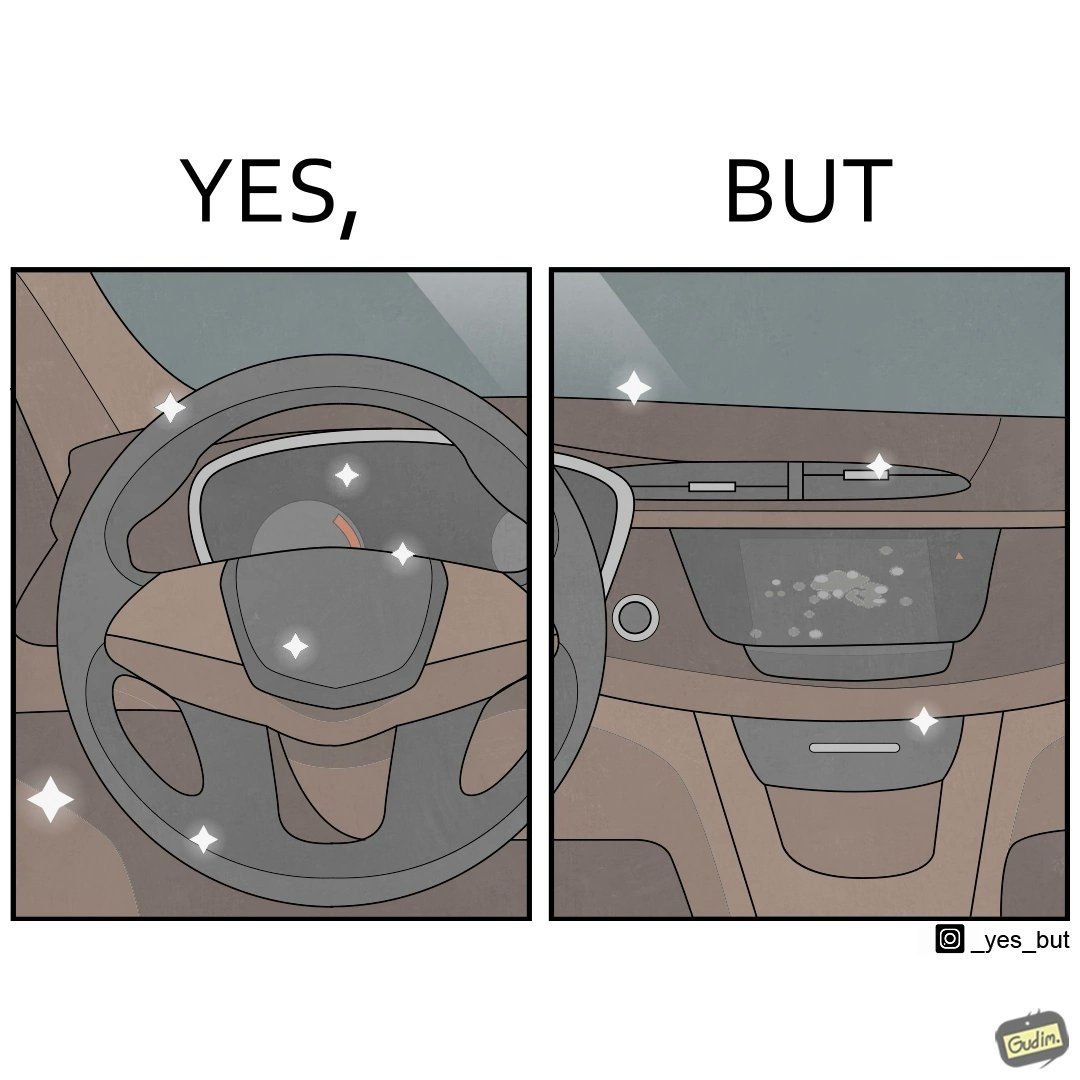Describe the contrast between the left and right parts of this image. In the left part of the image: sparkling steering wheel of a car. In the right part of the image: dashboard of a car, with the touch panel full of greasy fingerprints. 